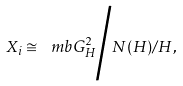Convert formula to latex. <formula><loc_0><loc_0><loc_500><loc_500>X _ { i } \cong \ m b G ^ { 2 } _ { H } \Big / N ( H ) / H ,</formula> 